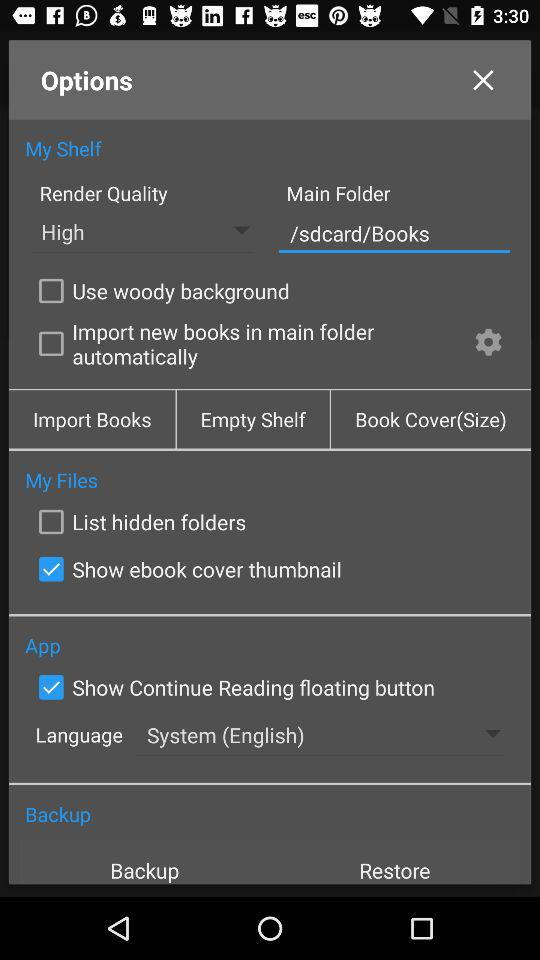Which option is marked as checked? The checked options are "Show ebook cover thumbnail" and "Show Continue Reading floating button". 